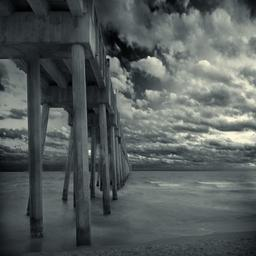In this task, you have to identify if the place or scene pictured is indoor or outdoor. In the image is among a total of 205 classes such as Hospital, Bridge, Courtyard, Motel,.... The classes of the images are a diverse set of places or scenes. Pay attention to the details as some of the images may contain an object that relates to a specific place while some images may directly show the place or scenary. So, your answer should be the place or scene shown in the image
Options: (a) Indoor (b) Outdoor The image distinctly depicts an outdoor setting. The expansive view showing the sky replete with cloud formations and a wide, tranquil body of water, clearly suggest an outside environment. The sandy shore and the wooden pier extending into the water are typical features of coastal outdoor scenes used for leisurely activities like walking, fishing, or simple contemplation of nature. The absence of any indoor attributes, such as walls or ceilings, further confirms the outdoor classification. Option (b) Outdoor accurately describes the scene in the image. 